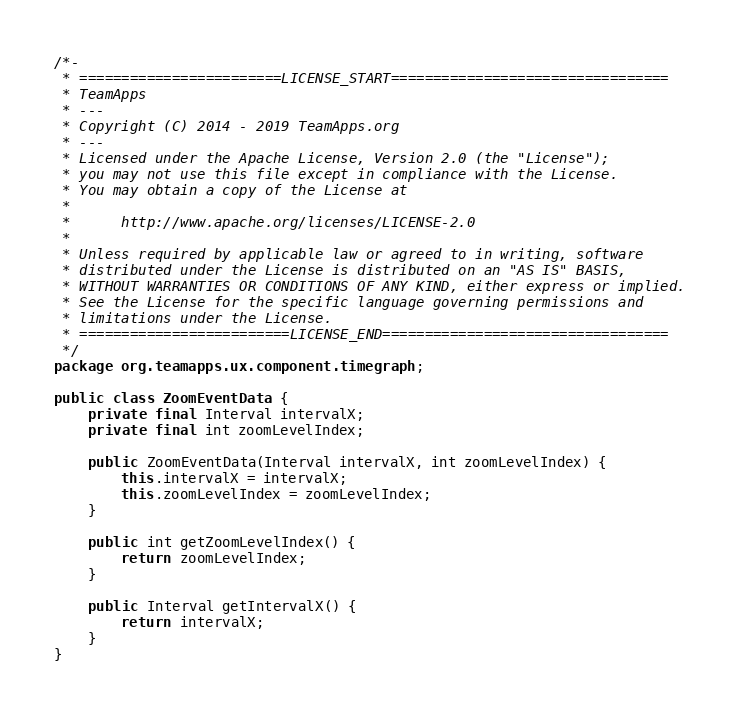<code> <loc_0><loc_0><loc_500><loc_500><_Java_>/*-
 * ========================LICENSE_START=================================
 * TeamApps
 * ---
 * Copyright (C) 2014 - 2019 TeamApps.org
 * ---
 * Licensed under the Apache License, Version 2.0 (the "License");
 * you may not use this file except in compliance with the License.
 * You may obtain a copy of the License at
 * 
 *      http://www.apache.org/licenses/LICENSE-2.0
 * 
 * Unless required by applicable law or agreed to in writing, software
 * distributed under the License is distributed on an "AS IS" BASIS,
 * WITHOUT WARRANTIES OR CONDITIONS OF ANY KIND, either express or implied.
 * See the License for the specific language governing permissions and
 * limitations under the License.
 * =========================LICENSE_END==================================
 */
package org.teamapps.ux.component.timegraph;

public class ZoomEventData {
	private final Interval intervalX;
	private final int zoomLevelIndex;

	public ZoomEventData(Interval intervalX, int zoomLevelIndex) {
		this.intervalX = intervalX;
		this.zoomLevelIndex = zoomLevelIndex;
	}

	public int getZoomLevelIndex() {
		return zoomLevelIndex;
	}

	public Interval getIntervalX() {
		return intervalX;
	}
}
</code> 